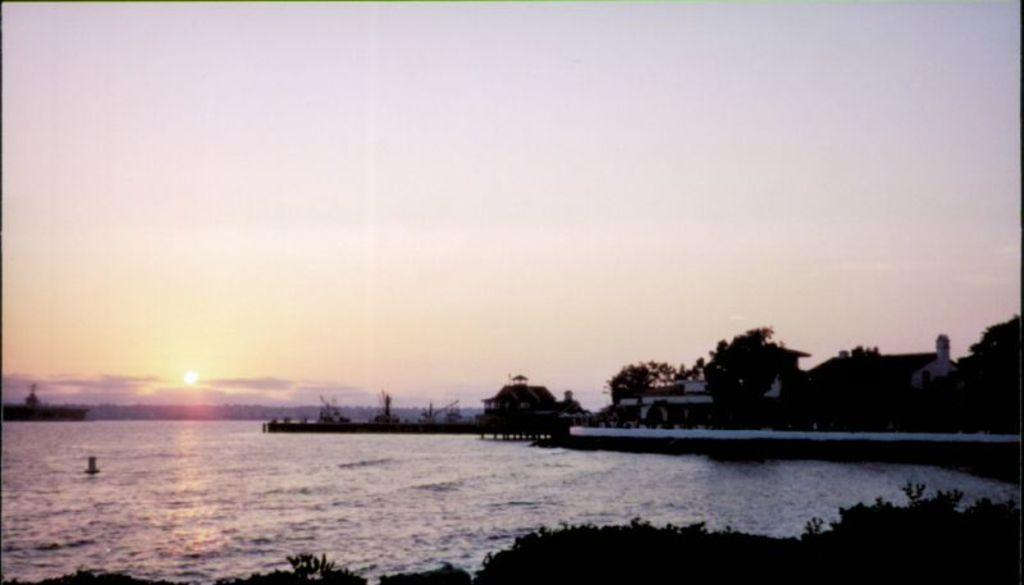What type of view is shown in the image? The image is an outside view. What can be seen on the right side of the image? There are trees and buildings on the right side of the image. What is visible on the left side of the image? There is a sea on the left side of the image. What is visible at the top of the image? The sky is visible at the top of the image. What celestial body can be seen in the sky? The sun is visible in the sky. What type of journey can be seen in the image? There is no journey visible in the image. 